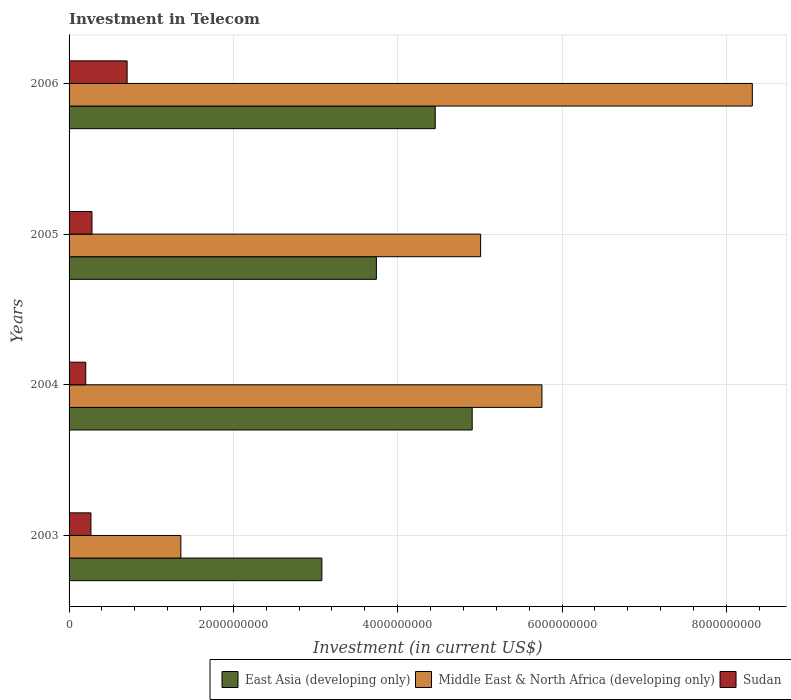How many different coloured bars are there?
Provide a short and direct response. 3. Are the number of bars per tick equal to the number of legend labels?
Make the answer very short. Yes. Are the number of bars on each tick of the Y-axis equal?
Your answer should be very brief. Yes. How many bars are there on the 4th tick from the top?
Your response must be concise. 3. What is the label of the 1st group of bars from the top?
Your answer should be very brief. 2006. What is the amount invested in telecom in Sudan in 2003?
Offer a terse response. 2.66e+08. Across all years, what is the maximum amount invested in telecom in Sudan?
Your answer should be very brief. 7.06e+08. Across all years, what is the minimum amount invested in telecom in East Asia (developing only)?
Provide a short and direct response. 3.08e+09. What is the total amount invested in telecom in Sudan in the graph?
Keep it short and to the point. 1.45e+09. What is the difference between the amount invested in telecom in East Asia (developing only) in 2003 and that in 2006?
Your answer should be very brief. -1.38e+09. What is the difference between the amount invested in telecom in Sudan in 2004 and the amount invested in telecom in Middle East & North Africa (developing only) in 2003?
Give a very brief answer. -1.16e+09. What is the average amount invested in telecom in Middle East & North Africa (developing only) per year?
Make the answer very short. 5.11e+09. In the year 2004, what is the difference between the amount invested in telecom in East Asia (developing only) and amount invested in telecom in Middle East & North Africa (developing only)?
Ensure brevity in your answer.  -8.49e+08. In how many years, is the amount invested in telecom in Middle East & North Africa (developing only) greater than 3200000000 US$?
Offer a very short reply. 3. What is the ratio of the amount invested in telecom in Middle East & North Africa (developing only) in 2004 to that in 2005?
Offer a terse response. 1.15. Is the amount invested in telecom in Middle East & North Africa (developing only) in 2004 less than that in 2006?
Your response must be concise. Yes. What is the difference between the highest and the second highest amount invested in telecom in East Asia (developing only)?
Offer a very short reply. 4.50e+08. What is the difference between the highest and the lowest amount invested in telecom in Middle East & North Africa (developing only)?
Keep it short and to the point. 6.96e+09. What does the 1st bar from the top in 2004 represents?
Provide a succinct answer. Sudan. What does the 3rd bar from the bottom in 2004 represents?
Keep it short and to the point. Sudan. How many bars are there?
Your answer should be compact. 12. Where does the legend appear in the graph?
Make the answer very short. Bottom right. How many legend labels are there?
Offer a terse response. 3. What is the title of the graph?
Provide a short and direct response. Investment in Telecom. What is the label or title of the X-axis?
Your answer should be compact. Investment (in current US$). What is the label or title of the Y-axis?
Your answer should be compact. Years. What is the Investment (in current US$) in East Asia (developing only) in 2003?
Provide a short and direct response. 3.08e+09. What is the Investment (in current US$) in Middle East & North Africa (developing only) in 2003?
Keep it short and to the point. 1.36e+09. What is the Investment (in current US$) of Sudan in 2003?
Give a very brief answer. 2.66e+08. What is the Investment (in current US$) of East Asia (developing only) in 2004?
Give a very brief answer. 4.91e+09. What is the Investment (in current US$) of Middle East & North Africa (developing only) in 2004?
Make the answer very short. 5.76e+09. What is the Investment (in current US$) of Sudan in 2004?
Make the answer very short. 2.03e+08. What is the Investment (in current US$) in East Asia (developing only) in 2005?
Make the answer very short. 3.74e+09. What is the Investment (in current US$) of Middle East & North Africa (developing only) in 2005?
Ensure brevity in your answer.  5.01e+09. What is the Investment (in current US$) of Sudan in 2005?
Ensure brevity in your answer.  2.78e+08. What is the Investment (in current US$) of East Asia (developing only) in 2006?
Provide a short and direct response. 4.46e+09. What is the Investment (in current US$) of Middle East & North Africa (developing only) in 2006?
Make the answer very short. 8.32e+09. What is the Investment (in current US$) in Sudan in 2006?
Provide a succinct answer. 7.06e+08. Across all years, what is the maximum Investment (in current US$) of East Asia (developing only)?
Ensure brevity in your answer.  4.91e+09. Across all years, what is the maximum Investment (in current US$) of Middle East & North Africa (developing only)?
Offer a terse response. 8.32e+09. Across all years, what is the maximum Investment (in current US$) in Sudan?
Provide a succinct answer. 7.06e+08. Across all years, what is the minimum Investment (in current US$) in East Asia (developing only)?
Your answer should be compact. 3.08e+09. Across all years, what is the minimum Investment (in current US$) of Middle East & North Africa (developing only)?
Ensure brevity in your answer.  1.36e+09. Across all years, what is the minimum Investment (in current US$) of Sudan?
Provide a succinct answer. 2.03e+08. What is the total Investment (in current US$) of East Asia (developing only) in the graph?
Your answer should be very brief. 1.62e+1. What is the total Investment (in current US$) in Middle East & North Africa (developing only) in the graph?
Ensure brevity in your answer.  2.04e+1. What is the total Investment (in current US$) of Sudan in the graph?
Ensure brevity in your answer.  1.45e+09. What is the difference between the Investment (in current US$) in East Asia (developing only) in 2003 and that in 2004?
Offer a terse response. -1.83e+09. What is the difference between the Investment (in current US$) of Middle East & North Africa (developing only) in 2003 and that in 2004?
Your answer should be compact. -4.40e+09. What is the difference between the Investment (in current US$) in Sudan in 2003 and that in 2004?
Ensure brevity in your answer.  6.32e+07. What is the difference between the Investment (in current US$) of East Asia (developing only) in 2003 and that in 2005?
Make the answer very short. -6.63e+08. What is the difference between the Investment (in current US$) of Middle East & North Africa (developing only) in 2003 and that in 2005?
Provide a succinct answer. -3.65e+09. What is the difference between the Investment (in current US$) of Sudan in 2003 and that in 2005?
Your answer should be compact. -1.23e+07. What is the difference between the Investment (in current US$) in East Asia (developing only) in 2003 and that in 2006?
Offer a terse response. -1.38e+09. What is the difference between the Investment (in current US$) in Middle East & North Africa (developing only) in 2003 and that in 2006?
Offer a terse response. -6.96e+09. What is the difference between the Investment (in current US$) in Sudan in 2003 and that in 2006?
Keep it short and to the point. -4.40e+08. What is the difference between the Investment (in current US$) of East Asia (developing only) in 2004 and that in 2005?
Your answer should be compact. 1.17e+09. What is the difference between the Investment (in current US$) of Middle East & North Africa (developing only) in 2004 and that in 2005?
Make the answer very short. 7.46e+08. What is the difference between the Investment (in current US$) in Sudan in 2004 and that in 2005?
Your answer should be very brief. -7.55e+07. What is the difference between the Investment (in current US$) of East Asia (developing only) in 2004 and that in 2006?
Your answer should be compact. 4.50e+08. What is the difference between the Investment (in current US$) of Middle East & North Africa (developing only) in 2004 and that in 2006?
Make the answer very short. -2.56e+09. What is the difference between the Investment (in current US$) in Sudan in 2004 and that in 2006?
Provide a short and direct response. -5.03e+08. What is the difference between the Investment (in current US$) of East Asia (developing only) in 2005 and that in 2006?
Your answer should be compact. -7.16e+08. What is the difference between the Investment (in current US$) in Middle East & North Africa (developing only) in 2005 and that in 2006?
Ensure brevity in your answer.  -3.31e+09. What is the difference between the Investment (in current US$) of Sudan in 2005 and that in 2006?
Provide a short and direct response. -4.28e+08. What is the difference between the Investment (in current US$) of East Asia (developing only) in 2003 and the Investment (in current US$) of Middle East & North Africa (developing only) in 2004?
Your answer should be compact. -2.68e+09. What is the difference between the Investment (in current US$) in East Asia (developing only) in 2003 and the Investment (in current US$) in Sudan in 2004?
Your answer should be compact. 2.87e+09. What is the difference between the Investment (in current US$) of Middle East & North Africa (developing only) in 2003 and the Investment (in current US$) of Sudan in 2004?
Provide a succinct answer. 1.16e+09. What is the difference between the Investment (in current US$) in East Asia (developing only) in 2003 and the Investment (in current US$) in Middle East & North Africa (developing only) in 2005?
Provide a short and direct response. -1.93e+09. What is the difference between the Investment (in current US$) of East Asia (developing only) in 2003 and the Investment (in current US$) of Sudan in 2005?
Keep it short and to the point. 2.80e+09. What is the difference between the Investment (in current US$) of Middle East & North Africa (developing only) in 2003 and the Investment (in current US$) of Sudan in 2005?
Provide a short and direct response. 1.08e+09. What is the difference between the Investment (in current US$) in East Asia (developing only) in 2003 and the Investment (in current US$) in Middle East & North Africa (developing only) in 2006?
Offer a very short reply. -5.24e+09. What is the difference between the Investment (in current US$) of East Asia (developing only) in 2003 and the Investment (in current US$) of Sudan in 2006?
Make the answer very short. 2.37e+09. What is the difference between the Investment (in current US$) of Middle East & North Africa (developing only) in 2003 and the Investment (in current US$) of Sudan in 2006?
Your answer should be very brief. 6.54e+08. What is the difference between the Investment (in current US$) in East Asia (developing only) in 2004 and the Investment (in current US$) in Middle East & North Africa (developing only) in 2005?
Offer a very short reply. -1.03e+08. What is the difference between the Investment (in current US$) of East Asia (developing only) in 2004 and the Investment (in current US$) of Sudan in 2005?
Ensure brevity in your answer.  4.63e+09. What is the difference between the Investment (in current US$) in Middle East & North Africa (developing only) in 2004 and the Investment (in current US$) in Sudan in 2005?
Make the answer very short. 5.48e+09. What is the difference between the Investment (in current US$) of East Asia (developing only) in 2004 and the Investment (in current US$) of Middle East & North Africa (developing only) in 2006?
Your answer should be very brief. -3.41e+09. What is the difference between the Investment (in current US$) in East Asia (developing only) in 2004 and the Investment (in current US$) in Sudan in 2006?
Offer a terse response. 4.20e+09. What is the difference between the Investment (in current US$) of Middle East & North Africa (developing only) in 2004 and the Investment (in current US$) of Sudan in 2006?
Provide a short and direct response. 5.05e+09. What is the difference between the Investment (in current US$) of East Asia (developing only) in 2005 and the Investment (in current US$) of Middle East & North Africa (developing only) in 2006?
Provide a short and direct response. -4.58e+09. What is the difference between the Investment (in current US$) of East Asia (developing only) in 2005 and the Investment (in current US$) of Sudan in 2006?
Your answer should be very brief. 3.03e+09. What is the difference between the Investment (in current US$) of Middle East & North Africa (developing only) in 2005 and the Investment (in current US$) of Sudan in 2006?
Ensure brevity in your answer.  4.30e+09. What is the average Investment (in current US$) of East Asia (developing only) per year?
Provide a short and direct response. 4.04e+09. What is the average Investment (in current US$) in Middle East & North Africa (developing only) per year?
Make the answer very short. 5.11e+09. What is the average Investment (in current US$) in Sudan per year?
Offer a very short reply. 3.64e+08. In the year 2003, what is the difference between the Investment (in current US$) in East Asia (developing only) and Investment (in current US$) in Middle East & North Africa (developing only)?
Give a very brief answer. 1.72e+09. In the year 2003, what is the difference between the Investment (in current US$) in East Asia (developing only) and Investment (in current US$) in Sudan?
Your response must be concise. 2.81e+09. In the year 2003, what is the difference between the Investment (in current US$) in Middle East & North Africa (developing only) and Investment (in current US$) in Sudan?
Provide a succinct answer. 1.09e+09. In the year 2004, what is the difference between the Investment (in current US$) in East Asia (developing only) and Investment (in current US$) in Middle East & North Africa (developing only)?
Make the answer very short. -8.49e+08. In the year 2004, what is the difference between the Investment (in current US$) of East Asia (developing only) and Investment (in current US$) of Sudan?
Make the answer very short. 4.70e+09. In the year 2004, what is the difference between the Investment (in current US$) in Middle East & North Africa (developing only) and Investment (in current US$) in Sudan?
Offer a very short reply. 5.55e+09. In the year 2005, what is the difference between the Investment (in current US$) in East Asia (developing only) and Investment (in current US$) in Middle East & North Africa (developing only)?
Provide a succinct answer. -1.27e+09. In the year 2005, what is the difference between the Investment (in current US$) of East Asia (developing only) and Investment (in current US$) of Sudan?
Keep it short and to the point. 3.46e+09. In the year 2005, what is the difference between the Investment (in current US$) of Middle East & North Africa (developing only) and Investment (in current US$) of Sudan?
Give a very brief answer. 4.73e+09. In the year 2006, what is the difference between the Investment (in current US$) in East Asia (developing only) and Investment (in current US$) in Middle East & North Africa (developing only)?
Make the answer very short. -3.86e+09. In the year 2006, what is the difference between the Investment (in current US$) of East Asia (developing only) and Investment (in current US$) of Sudan?
Offer a terse response. 3.75e+09. In the year 2006, what is the difference between the Investment (in current US$) of Middle East & North Africa (developing only) and Investment (in current US$) of Sudan?
Your response must be concise. 7.61e+09. What is the ratio of the Investment (in current US$) of East Asia (developing only) in 2003 to that in 2004?
Keep it short and to the point. 0.63. What is the ratio of the Investment (in current US$) in Middle East & North Africa (developing only) in 2003 to that in 2004?
Provide a succinct answer. 0.24. What is the ratio of the Investment (in current US$) of Sudan in 2003 to that in 2004?
Your answer should be compact. 1.31. What is the ratio of the Investment (in current US$) of East Asia (developing only) in 2003 to that in 2005?
Offer a very short reply. 0.82. What is the ratio of the Investment (in current US$) of Middle East & North Africa (developing only) in 2003 to that in 2005?
Provide a succinct answer. 0.27. What is the ratio of the Investment (in current US$) in Sudan in 2003 to that in 2005?
Offer a terse response. 0.96. What is the ratio of the Investment (in current US$) of East Asia (developing only) in 2003 to that in 2006?
Provide a succinct answer. 0.69. What is the ratio of the Investment (in current US$) in Middle East & North Africa (developing only) in 2003 to that in 2006?
Make the answer very short. 0.16. What is the ratio of the Investment (in current US$) of Sudan in 2003 to that in 2006?
Your response must be concise. 0.38. What is the ratio of the Investment (in current US$) in East Asia (developing only) in 2004 to that in 2005?
Provide a succinct answer. 1.31. What is the ratio of the Investment (in current US$) of Middle East & North Africa (developing only) in 2004 to that in 2005?
Offer a terse response. 1.15. What is the ratio of the Investment (in current US$) of Sudan in 2004 to that in 2005?
Your answer should be very brief. 0.73. What is the ratio of the Investment (in current US$) in East Asia (developing only) in 2004 to that in 2006?
Provide a succinct answer. 1.1. What is the ratio of the Investment (in current US$) of Middle East & North Africa (developing only) in 2004 to that in 2006?
Keep it short and to the point. 0.69. What is the ratio of the Investment (in current US$) in Sudan in 2004 to that in 2006?
Your response must be concise. 0.29. What is the ratio of the Investment (in current US$) in East Asia (developing only) in 2005 to that in 2006?
Your response must be concise. 0.84. What is the ratio of the Investment (in current US$) in Middle East & North Africa (developing only) in 2005 to that in 2006?
Your answer should be compact. 0.6. What is the ratio of the Investment (in current US$) of Sudan in 2005 to that in 2006?
Give a very brief answer. 0.39. What is the difference between the highest and the second highest Investment (in current US$) in East Asia (developing only)?
Ensure brevity in your answer.  4.50e+08. What is the difference between the highest and the second highest Investment (in current US$) of Middle East & North Africa (developing only)?
Your answer should be compact. 2.56e+09. What is the difference between the highest and the second highest Investment (in current US$) in Sudan?
Your answer should be compact. 4.28e+08. What is the difference between the highest and the lowest Investment (in current US$) in East Asia (developing only)?
Your answer should be very brief. 1.83e+09. What is the difference between the highest and the lowest Investment (in current US$) in Middle East & North Africa (developing only)?
Offer a terse response. 6.96e+09. What is the difference between the highest and the lowest Investment (in current US$) in Sudan?
Provide a short and direct response. 5.03e+08. 